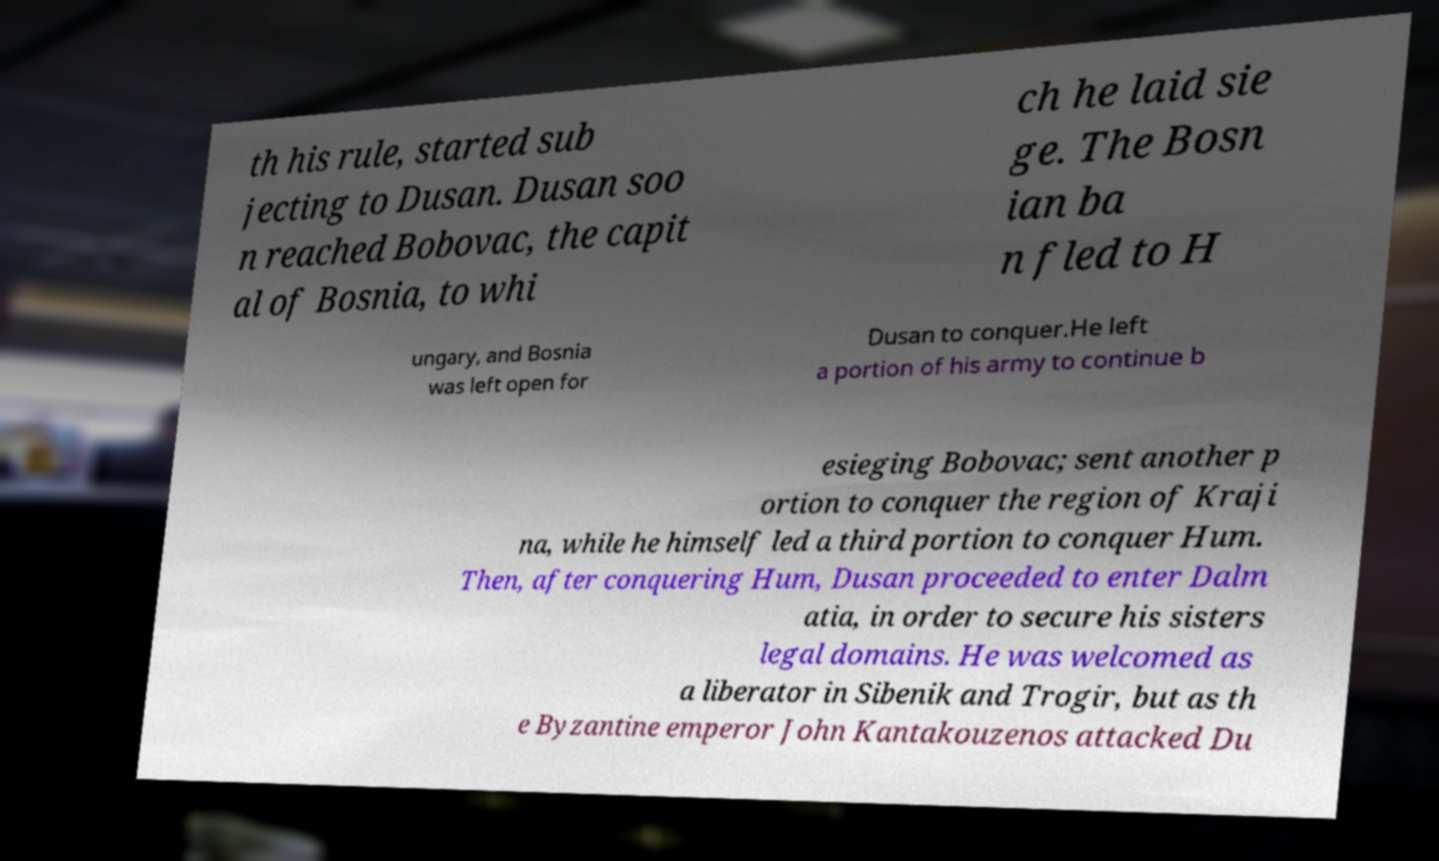Could you extract and type out the text from this image? th his rule, started sub jecting to Dusan. Dusan soo n reached Bobovac, the capit al of Bosnia, to whi ch he laid sie ge. The Bosn ian ba n fled to H ungary, and Bosnia was left open for Dusan to conquer.He left a portion of his army to continue b esieging Bobovac; sent another p ortion to conquer the region of Kraji na, while he himself led a third portion to conquer Hum. Then, after conquering Hum, Dusan proceeded to enter Dalm atia, in order to secure his sisters legal domains. He was welcomed as a liberator in Sibenik and Trogir, but as th e Byzantine emperor John Kantakouzenos attacked Du 